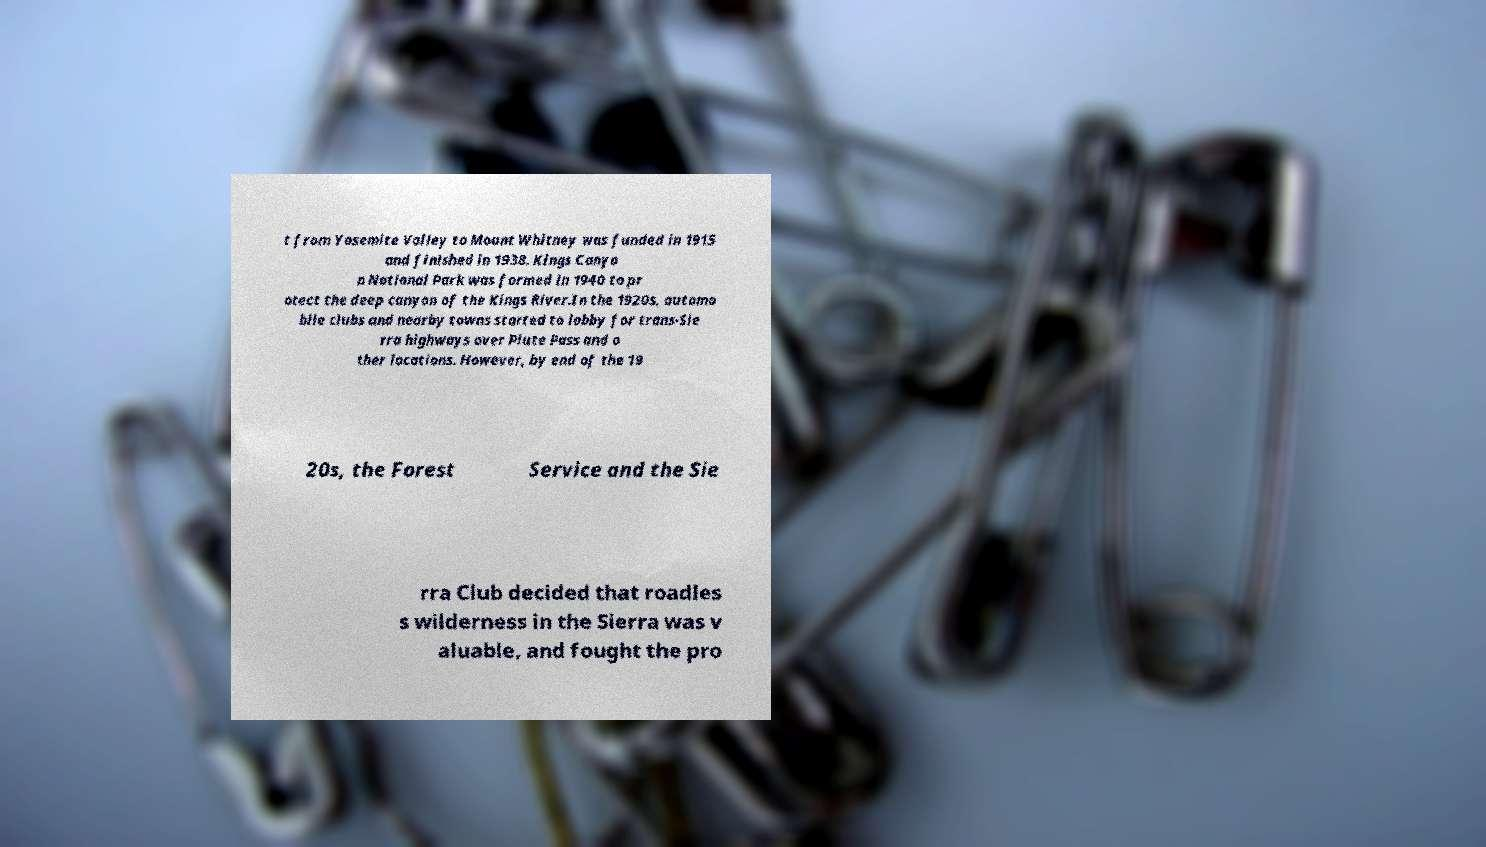I need the written content from this picture converted into text. Can you do that? t from Yosemite Valley to Mount Whitney was funded in 1915 and finished in 1938. Kings Canyo n National Park was formed in 1940 to pr otect the deep canyon of the Kings River.In the 1920s, automo bile clubs and nearby towns started to lobby for trans-Sie rra highways over Piute Pass and o ther locations. However, by end of the 19 20s, the Forest Service and the Sie rra Club decided that roadles s wilderness in the Sierra was v aluable, and fought the pro 